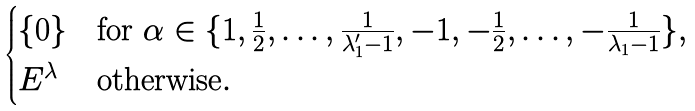Convert formula to latex. <formula><loc_0><loc_0><loc_500><loc_500>\begin{cases} \{ 0 \} & \text {for $\alpha \in \{ 1, \frac{1}{2}, \dots, \frac{1}{\lambda_{1}^{\prime}-1}, -1, -\frac{1}{2}, \dots, -\frac{1}{\lambda_{1}-1}\}$} , \\ E ^ { \lambda } & \text {otherwise} . \end{cases}</formula> 